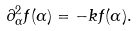<formula> <loc_0><loc_0><loc_500><loc_500>\partial ^ { 2 } _ { \alpha } f ( \alpha ) = - k f ( \alpha ) .</formula> 